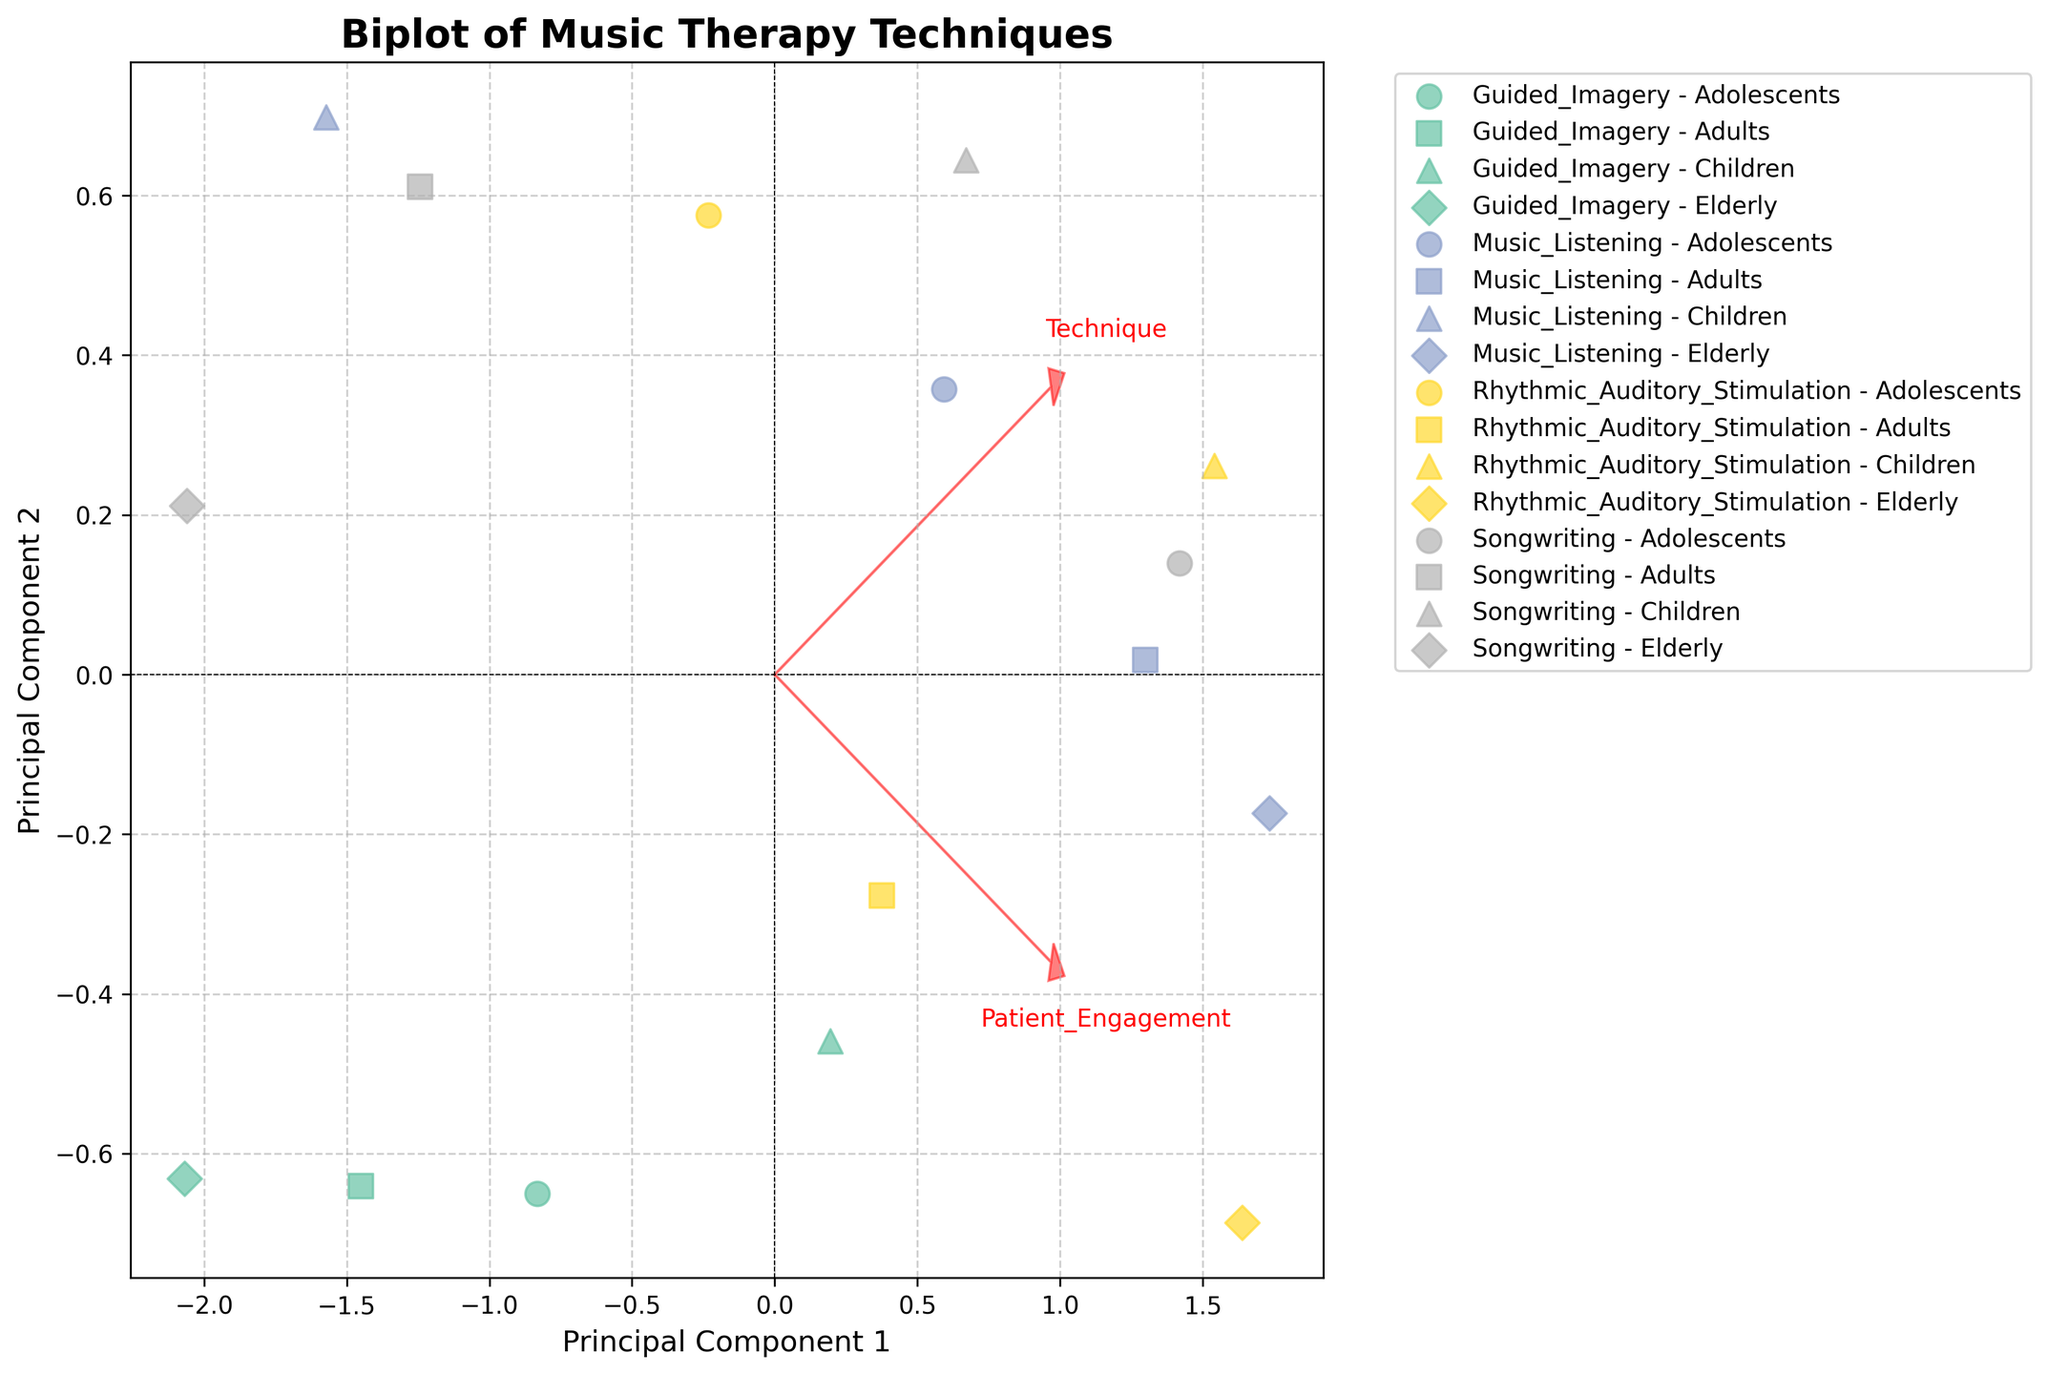What is the title of the plot? The title of the plot is displayed prominently at the top of the chart. It reads "Biplot of Music Therapy Techniques."
Answer: Biplot of Music Therapy Techniques What do the x and y axes represent? The x-axis is labeled "Principal Component 1" and the y-axis is labeled "Principal Component 2," which means they represent the first and second principal components from the PCA analysis respectively.
Answer: Principal Component 1 and Principal Component 2 Which music therapy technique has the highest patient engagement for children? We need to look for data points with the label indicating the technique and age group as children. Among these, we find the maximum value on the x-axis. Rhythmic Auditory Stimulation has the highest patient engagement.
Answer: Rhythmic Auditory Stimulation For elderly patients, which technique shows higher effectiveness, Guided Imagery or Rhythmic Auditory Stimulation? By observing the plot, we compare the positions of Guided Imagery and Rhythmic Auditory Stimulation under the elderly group on the y-axis. Rhythmic Auditory Stimulation has a higher value on the y-axis, indicating higher effectiveness.
Answer: Rhythmic Auditory Stimulation How many distinct markers are used to represent age groups? The plot uses different markers to represent distinct age groups. By counting these markers, we find there are four distinct markers.
Answer: 4 Which technique appears to be the least effective across all age groups? By analyzing the plot, we look for the technique that consistently shows lower positions on the y-axis across all age groups. Guided Imagery consistently appears lower in effectiveness.
Answer: Guided Imagery Which music therapy technique has the highest effectiveness for adults? To find this, locate the data points for adults and check the one with the highest value on the y-axis. Music Listening has the highest effectiveness for adults.
Answer: Music Listening Do any techniques fall in the negative for both principal components? This involves checking if any data points are in the bottom-left quadrant of the axes, which indicates negative values for both components. None of the techniques fall in the negative for both principal components.
Answer: No Which age group generally experiences the highest patient engagement with Music Listening? We need to compare the marker positions for Music Listening across different age groups on the x-axis. Elderly patients have the highest patient engagement with Music Listening.
Answer: Elderly Does Songwriting show more variation in effectiveness or patient engagement across age groups? We compare how spread-out the points labeled as Songwriting are along the x (patient engagement) and y (effectiveness) axes. The points for Songwriting are more spread on the x-axis, showing more variation in patient engagement.
Answer: Patient Engagement 